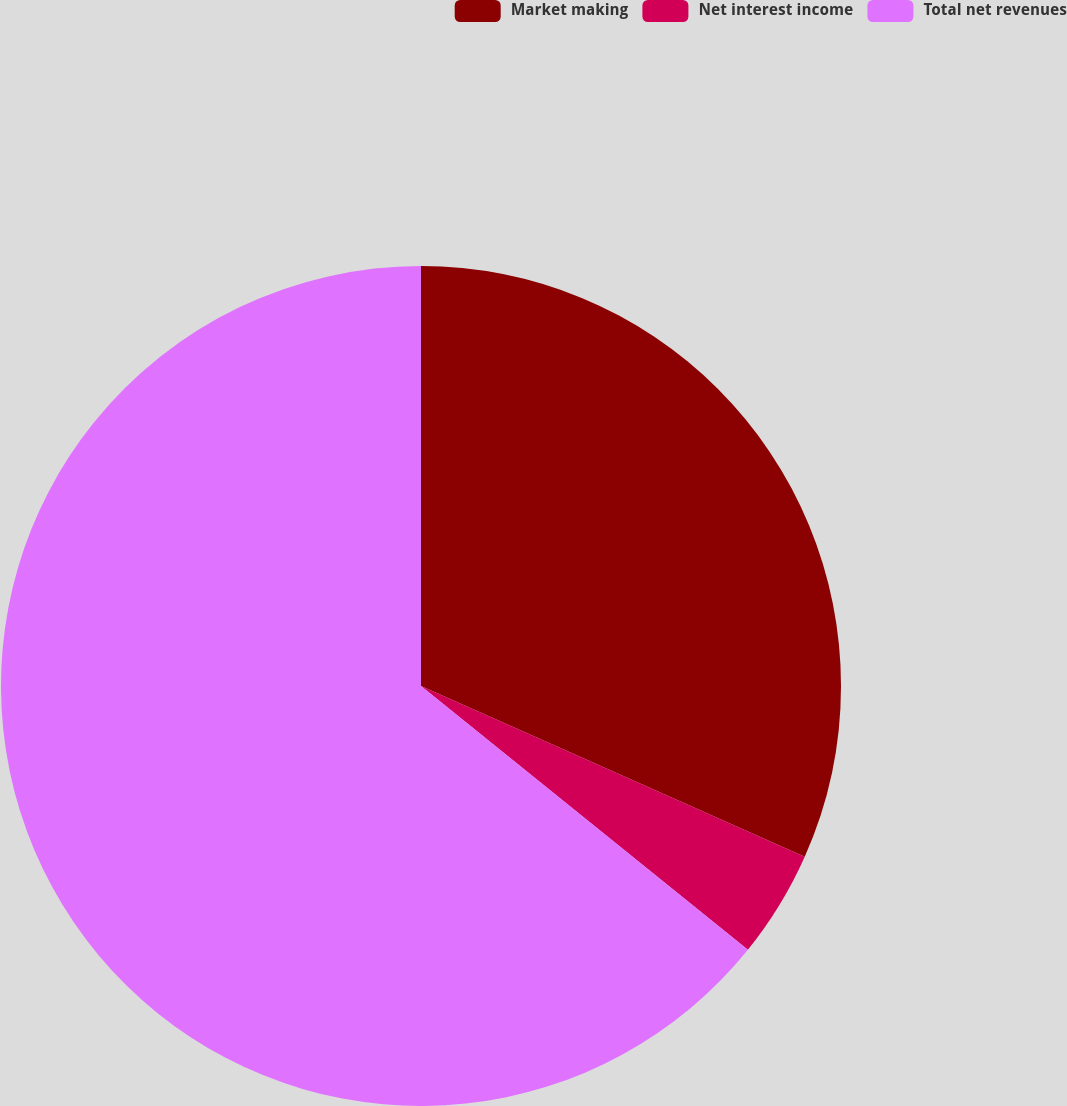Convert chart. <chart><loc_0><loc_0><loc_500><loc_500><pie_chart><fcel>Market making<fcel>Net interest income<fcel>Total net revenues<nl><fcel>31.66%<fcel>4.14%<fcel>64.19%<nl></chart> 